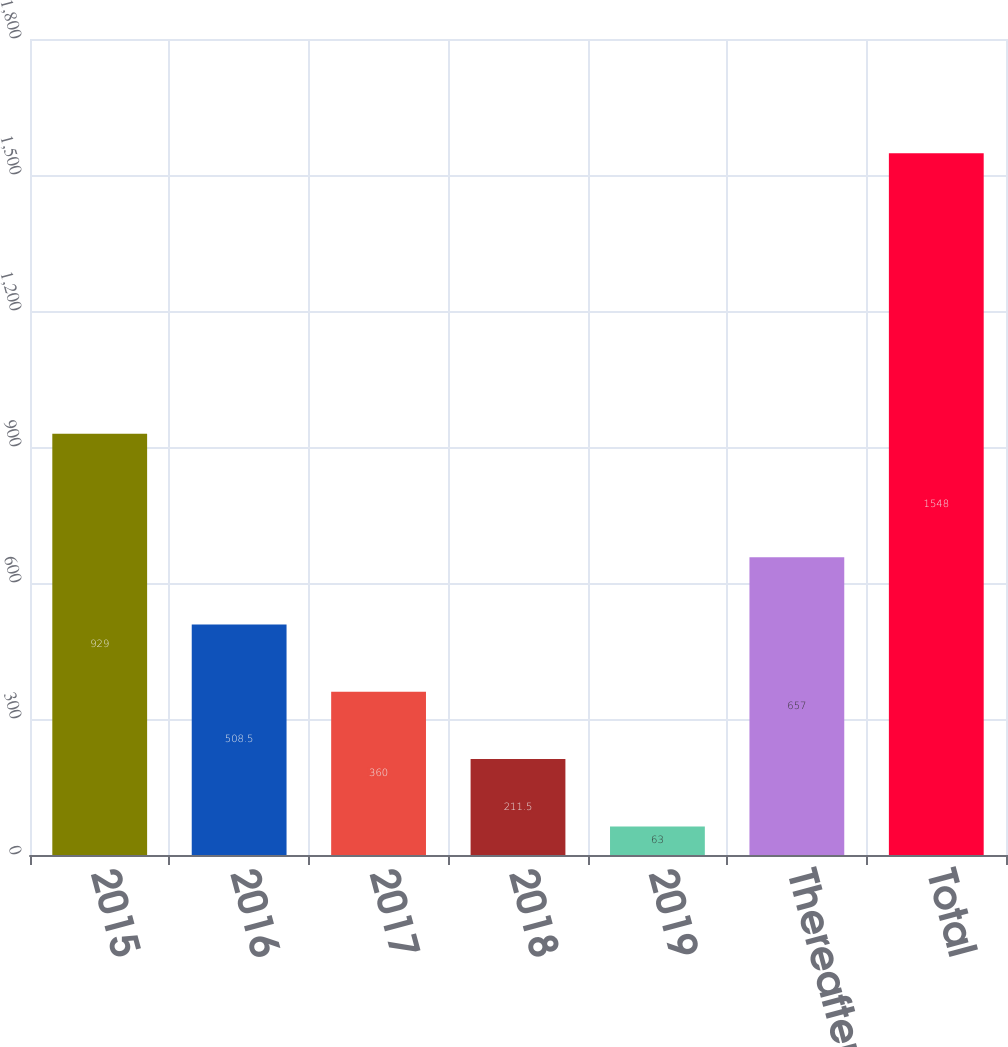Convert chart to OTSL. <chart><loc_0><loc_0><loc_500><loc_500><bar_chart><fcel>2015<fcel>2016<fcel>2017<fcel>2018<fcel>2019<fcel>Thereafter<fcel>Total<nl><fcel>929<fcel>508.5<fcel>360<fcel>211.5<fcel>63<fcel>657<fcel>1548<nl></chart> 